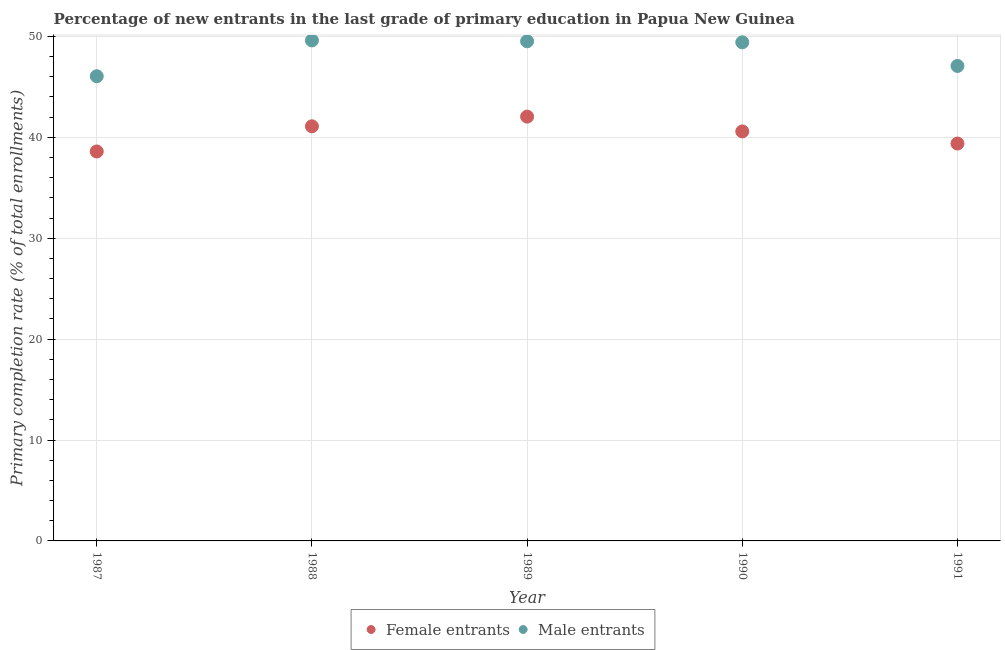How many different coloured dotlines are there?
Give a very brief answer. 2. What is the primary completion rate of male entrants in 1990?
Your answer should be very brief. 49.41. Across all years, what is the maximum primary completion rate of male entrants?
Offer a very short reply. 49.6. Across all years, what is the minimum primary completion rate of male entrants?
Ensure brevity in your answer.  46.05. In which year was the primary completion rate of female entrants maximum?
Keep it short and to the point. 1989. What is the total primary completion rate of female entrants in the graph?
Your response must be concise. 201.7. What is the difference between the primary completion rate of female entrants in 1987 and that in 1990?
Keep it short and to the point. -1.99. What is the difference between the primary completion rate of female entrants in 1989 and the primary completion rate of male entrants in 1991?
Your answer should be compact. -5.02. What is the average primary completion rate of male entrants per year?
Keep it short and to the point. 48.33. In the year 1988, what is the difference between the primary completion rate of female entrants and primary completion rate of male entrants?
Offer a very short reply. -8.51. What is the ratio of the primary completion rate of male entrants in 1988 to that in 1991?
Your answer should be very brief. 1.05. Is the primary completion rate of male entrants in 1987 less than that in 1988?
Give a very brief answer. Yes. What is the difference between the highest and the second highest primary completion rate of female entrants?
Provide a succinct answer. 0.96. What is the difference between the highest and the lowest primary completion rate of female entrants?
Give a very brief answer. 3.45. Is the primary completion rate of male entrants strictly greater than the primary completion rate of female entrants over the years?
Offer a terse response. Yes. Where does the legend appear in the graph?
Keep it short and to the point. Bottom center. How many legend labels are there?
Offer a terse response. 2. What is the title of the graph?
Make the answer very short. Percentage of new entrants in the last grade of primary education in Papua New Guinea. What is the label or title of the Y-axis?
Offer a terse response. Primary completion rate (% of total enrollments). What is the Primary completion rate (% of total enrollments) in Female entrants in 1987?
Offer a terse response. 38.59. What is the Primary completion rate (% of total enrollments) in Male entrants in 1987?
Your answer should be compact. 46.05. What is the Primary completion rate (% of total enrollments) in Female entrants in 1988?
Offer a very short reply. 41.09. What is the Primary completion rate (% of total enrollments) in Male entrants in 1988?
Provide a short and direct response. 49.6. What is the Primary completion rate (% of total enrollments) of Female entrants in 1989?
Keep it short and to the point. 42.05. What is the Primary completion rate (% of total enrollments) in Male entrants in 1989?
Provide a short and direct response. 49.52. What is the Primary completion rate (% of total enrollments) in Female entrants in 1990?
Ensure brevity in your answer.  40.58. What is the Primary completion rate (% of total enrollments) in Male entrants in 1990?
Give a very brief answer. 49.41. What is the Primary completion rate (% of total enrollments) in Female entrants in 1991?
Offer a very short reply. 39.38. What is the Primary completion rate (% of total enrollments) of Male entrants in 1991?
Offer a very short reply. 47.07. Across all years, what is the maximum Primary completion rate (% of total enrollments) of Female entrants?
Your answer should be compact. 42.05. Across all years, what is the maximum Primary completion rate (% of total enrollments) in Male entrants?
Make the answer very short. 49.6. Across all years, what is the minimum Primary completion rate (% of total enrollments) of Female entrants?
Provide a succinct answer. 38.59. Across all years, what is the minimum Primary completion rate (% of total enrollments) of Male entrants?
Your answer should be very brief. 46.05. What is the total Primary completion rate (% of total enrollments) of Female entrants in the graph?
Offer a very short reply. 201.7. What is the total Primary completion rate (% of total enrollments) of Male entrants in the graph?
Ensure brevity in your answer.  241.65. What is the difference between the Primary completion rate (% of total enrollments) of Female entrants in 1987 and that in 1988?
Provide a succinct answer. -2.49. What is the difference between the Primary completion rate (% of total enrollments) of Male entrants in 1987 and that in 1988?
Offer a terse response. -3.55. What is the difference between the Primary completion rate (% of total enrollments) of Female entrants in 1987 and that in 1989?
Offer a terse response. -3.45. What is the difference between the Primary completion rate (% of total enrollments) in Male entrants in 1987 and that in 1989?
Your response must be concise. -3.46. What is the difference between the Primary completion rate (% of total enrollments) in Female entrants in 1987 and that in 1990?
Offer a very short reply. -1.99. What is the difference between the Primary completion rate (% of total enrollments) in Male entrants in 1987 and that in 1990?
Provide a succinct answer. -3.36. What is the difference between the Primary completion rate (% of total enrollments) in Female entrants in 1987 and that in 1991?
Your response must be concise. -0.79. What is the difference between the Primary completion rate (% of total enrollments) in Male entrants in 1987 and that in 1991?
Offer a terse response. -1.02. What is the difference between the Primary completion rate (% of total enrollments) in Female entrants in 1988 and that in 1989?
Provide a succinct answer. -0.96. What is the difference between the Primary completion rate (% of total enrollments) of Male entrants in 1988 and that in 1989?
Ensure brevity in your answer.  0.08. What is the difference between the Primary completion rate (% of total enrollments) of Female entrants in 1988 and that in 1990?
Offer a very short reply. 0.51. What is the difference between the Primary completion rate (% of total enrollments) in Male entrants in 1988 and that in 1990?
Make the answer very short. 0.19. What is the difference between the Primary completion rate (% of total enrollments) in Female entrants in 1988 and that in 1991?
Provide a short and direct response. 1.71. What is the difference between the Primary completion rate (% of total enrollments) of Male entrants in 1988 and that in 1991?
Make the answer very short. 2.53. What is the difference between the Primary completion rate (% of total enrollments) of Female entrants in 1989 and that in 1990?
Provide a short and direct response. 1.47. What is the difference between the Primary completion rate (% of total enrollments) of Male entrants in 1989 and that in 1990?
Your response must be concise. 0.1. What is the difference between the Primary completion rate (% of total enrollments) of Female entrants in 1989 and that in 1991?
Make the answer very short. 2.67. What is the difference between the Primary completion rate (% of total enrollments) of Male entrants in 1989 and that in 1991?
Make the answer very short. 2.45. What is the difference between the Primary completion rate (% of total enrollments) in Female entrants in 1990 and that in 1991?
Offer a very short reply. 1.2. What is the difference between the Primary completion rate (% of total enrollments) in Male entrants in 1990 and that in 1991?
Your answer should be compact. 2.34. What is the difference between the Primary completion rate (% of total enrollments) in Female entrants in 1987 and the Primary completion rate (% of total enrollments) in Male entrants in 1988?
Keep it short and to the point. -11. What is the difference between the Primary completion rate (% of total enrollments) of Female entrants in 1987 and the Primary completion rate (% of total enrollments) of Male entrants in 1989?
Offer a very short reply. -10.92. What is the difference between the Primary completion rate (% of total enrollments) in Female entrants in 1987 and the Primary completion rate (% of total enrollments) in Male entrants in 1990?
Your answer should be compact. -10.82. What is the difference between the Primary completion rate (% of total enrollments) of Female entrants in 1987 and the Primary completion rate (% of total enrollments) of Male entrants in 1991?
Ensure brevity in your answer.  -8.47. What is the difference between the Primary completion rate (% of total enrollments) in Female entrants in 1988 and the Primary completion rate (% of total enrollments) in Male entrants in 1989?
Your response must be concise. -8.43. What is the difference between the Primary completion rate (% of total enrollments) of Female entrants in 1988 and the Primary completion rate (% of total enrollments) of Male entrants in 1990?
Ensure brevity in your answer.  -8.33. What is the difference between the Primary completion rate (% of total enrollments) of Female entrants in 1988 and the Primary completion rate (% of total enrollments) of Male entrants in 1991?
Offer a very short reply. -5.98. What is the difference between the Primary completion rate (% of total enrollments) of Female entrants in 1989 and the Primary completion rate (% of total enrollments) of Male entrants in 1990?
Ensure brevity in your answer.  -7.36. What is the difference between the Primary completion rate (% of total enrollments) in Female entrants in 1989 and the Primary completion rate (% of total enrollments) in Male entrants in 1991?
Your response must be concise. -5.02. What is the difference between the Primary completion rate (% of total enrollments) of Female entrants in 1990 and the Primary completion rate (% of total enrollments) of Male entrants in 1991?
Your response must be concise. -6.49. What is the average Primary completion rate (% of total enrollments) of Female entrants per year?
Your answer should be compact. 40.34. What is the average Primary completion rate (% of total enrollments) in Male entrants per year?
Offer a very short reply. 48.33. In the year 1987, what is the difference between the Primary completion rate (% of total enrollments) in Female entrants and Primary completion rate (% of total enrollments) in Male entrants?
Offer a very short reply. -7.46. In the year 1988, what is the difference between the Primary completion rate (% of total enrollments) of Female entrants and Primary completion rate (% of total enrollments) of Male entrants?
Your answer should be compact. -8.51. In the year 1989, what is the difference between the Primary completion rate (% of total enrollments) in Female entrants and Primary completion rate (% of total enrollments) in Male entrants?
Your answer should be compact. -7.47. In the year 1990, what is the difference between the Primary completion rate (% of total enrollments) in Female entrants and Primary completion rate (% of total enrollments) in Male entrants?
Your answer should be very brief. -8.83. In the year 1991, what is the difference between the Primary completion rate (% of total enrollments) of Female entrants and Primary completion rate (% of total enrollments) of Male entrants?
Your response must be concise. -7.69. What is the ratio of the Primary completion rate (% of total enrollments) in Female entrants in 1987 to that in 1988?
Keep it short and to the point. 0.94. What is the ratio of the Primary completion rate (% of total enrollments) of Male entrants in 1987 to that in 1988?
Make the answer very short. 0.93. What is the ratio of the Primary completion rate (% of total enrollments) of Female entrants in 1987 to that in 1989?
Keep it short and to the point. 0.92. What is the ratio of the Primary completion rate (% of total enrollments) of Male entrants in 1987 to that in 1989?
Your answer should be very brief. 0.93. What is the ratio of the Primary completion rate (% of total enrollments) in Female entrants in 1987 to that in 1990?
Ensure brevity in your answer.  0.95. What is the ratio of the Primary completion rate (% of total enrollments) in Male entrants in 1987 to that in 1990?
Your answer should be very brief. 0.93. What is the ratio of the Primary completion rate (% of total enrollments) of Female entrants in 1987 to that in 1991?
Offer a terse response. 0.98. What is the ratio of the Primary completion rate (% of total enrollments) of Male entrants in 1987 to that in 1991?
Offer a very short reply. 0.98. What is the ratio of the Primary completion rate (% of total enrollments) of Female entrants in 1988 to that in 1989?
Your answer should be compact. 0.98. What is the ratio of the Primary completion rate (% of total enrollments) in Female entrants in 1988 to that in 1990?
Your answer should be very brief. 1.01. What is the ratio of the Primary completion rate (% of total enrollments) of Male entrants in 1988 to that in 1990?
Your answer should be compact. 1. What is the ratio of the Primary completion rate (% of total enrollments) in Female entrants in 1988 to that in 1991?
Provide a short and direct response. 1.04. What is the ratio of the Primary completion rate (% of total enrollments) in Male entrants in 1988 to that in 1991?
Provide a short and direct response. 1.05. What is the ratio of the Primary completion rate (% of total enrollments) in Female entrants in 1989 to that in 1990?
Offer a very short reply. 1.04. What is the ratio of the Primary completion rate (% of total enrollments) of Female entrants in 1989 to that in 1991?
Provide a short and direct response. 1.07. What is the ratio of the Primary completion rate (% of total enrollments) in Male entrants in 1989 to that in 1991?
Give a very brief answer. 1.05. What is the ratio of the Primary completion rate (% of total enrollments) in Female entrants in 1990 to that in 1991?
Your response must be concise. 1.03. What is the ratio of the Primary completion rate (% of total enrollments) in Male entrants in 1990 to that in 1991?
Make the answer very short. 1.05. What is the difference between the highest and the second highest Primary completion rate (% of total enrollments) in Female entrants?
Offer a terse response. 0.96. What is the difference between the highest and the second highest Primary completion rate (% of total enrollments) in Male entrants?
Your response must be concise. 0.08. What is the difference between the highest and the lowest Primary completion rate (% of total enrollments) in Female entrants?
Provide a short and direct response. 3.45. What is the difference between the highest and the lowest Primary completion rate (% of total enrollments) in Male entrants?
Give a very brief answer. 3.55. 